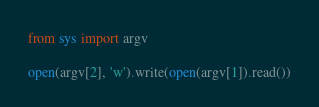Convert code to text. <code><loc_0><loc_0><loc_500><loc_500><_Python_>from sys import argv

open(argv[2], 'w').write(open(argv[1]).read())
</code> 